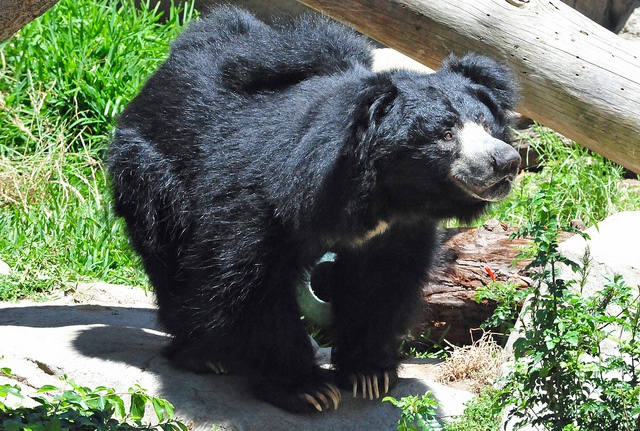Describe the objects in this image and their specific colors. I can see a bear in gray, black, and darkgray tones in this image. 